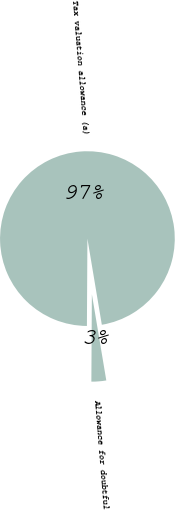Convert chart to OTSL. <chart><loc_0><loc_0><loc_500><loc_500><pie_chart><fcel>Allowance for doubtful<fcel>Tax valuation allowance (a)<nl><fcel>2.73%<fcel>97.27%<nl></chart> 